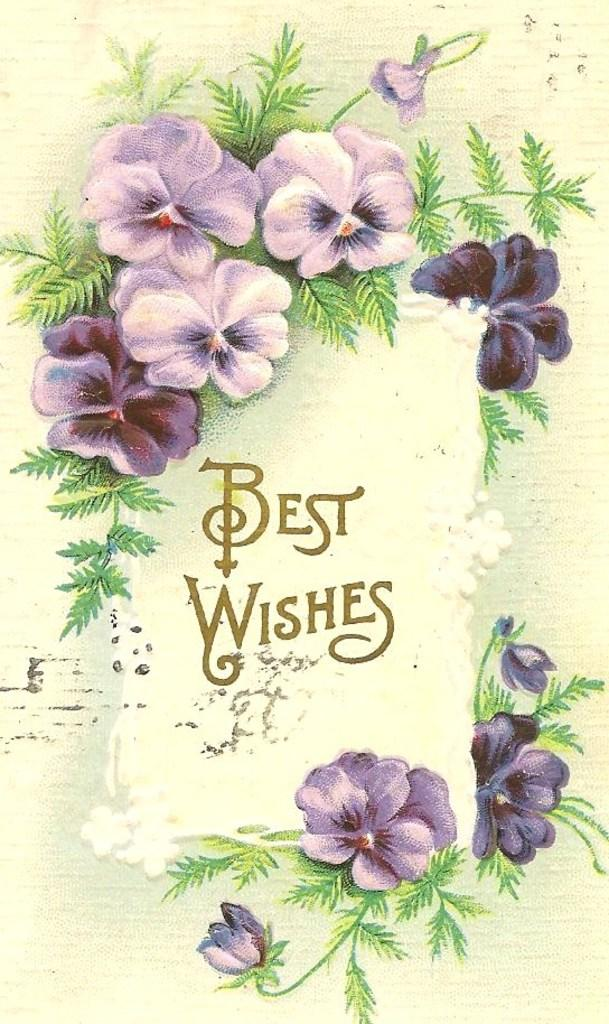What type of visual representation is shown in the image? The image is a poster. What is depicted on the poster? The poster contains animated images of plants. What features do the plants have? The plants have flowers and leaves. Are there any words or phrases on the poster? Yes, there are texts on the poster. What color is the background of the poster? The background of the poster is cream in color. What type of battle is depicted in the poster? There is no battle depicted in the poster; it features animated images of plants with flowers and leaves. What does the sister of the person who created the poster look like? The provided facts do not mention any information about the creator of the poster or their sister, so we cannot answer this question. 